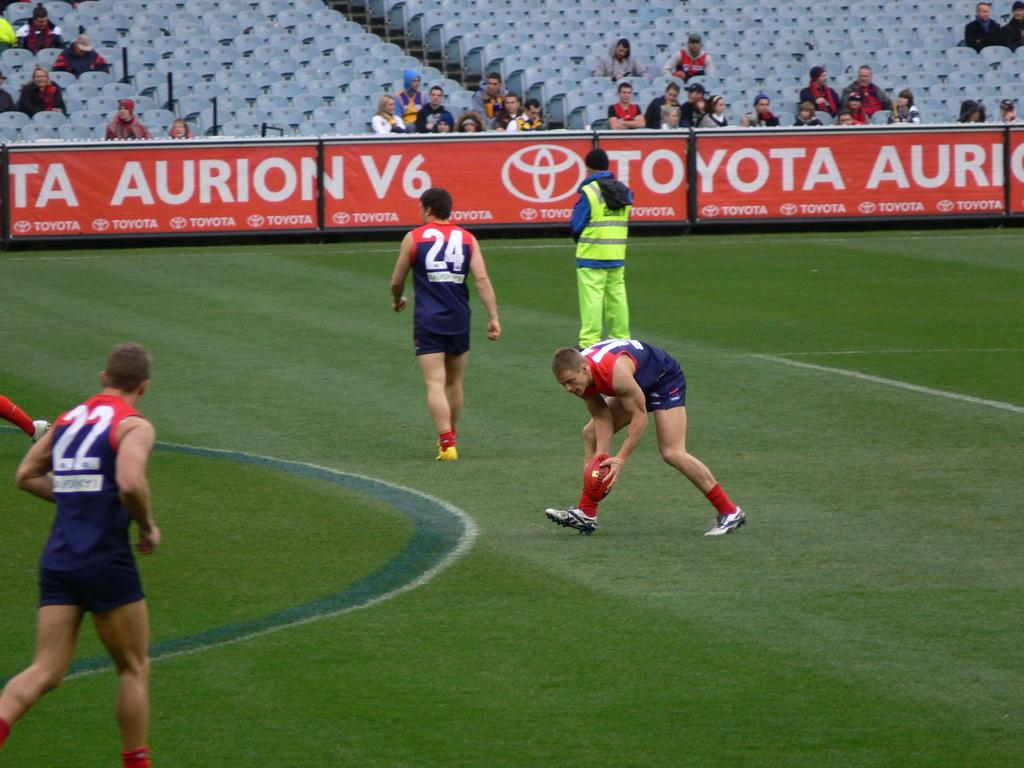<image>
Share a concise interpretation of the image provided. The side of a rugby stadium is covered with advertisements for Toyota. 